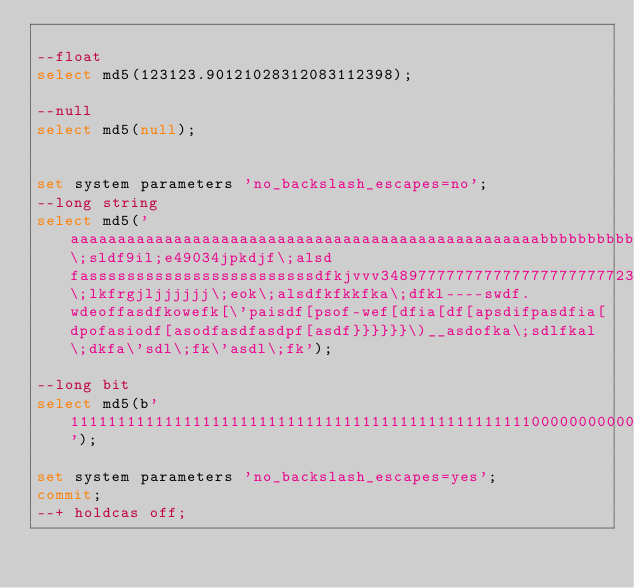<code> <loc_0><loc_0><loc_500><loc_500><_SQL_>
--float
select md5(123123.90121028312083112398);

--null
select md5(null);


set system parameters 'no_backslash_escapes=no';
--long string
select md5('aaaaaaaaaaaaaaaaaaaaaaaaaaaaaaaaaaaaaaaaaaaaaaaaaabbbbbbbbbbbbbbbbbbbbbbbbbbbbblj\;sldf9il;e49034jpkdjf\;alsd fassssssssssssssssssssssssdfkjvvv3489777777777777777777777239488302938402934888888888888880980928340928340289340823498209gks\;lkfrgjljjjjjj\;eok\;alsdfkfkkfka\;dfkl----swdf.wdeoffasdfkowefk[\'paisdf[psof-wef[dfia[df[apsdifpasdfia[dpofasiodf[asodfasdfasdpf[asdf}}}}}}\)__asdofka\;sdlfkal\;dkfa\'sdl\;fk\'asdl\;fk');

--long bit
select md5(b'11111111111111111111111111111111111111111111111110000000000000000000000000000011111111111111111111111111111111111111111111111111111111111111100000000000000000000000000000000000000011111111111111111111111111111111111111111111000000000000000000000000000000000000000000000000000001');

set system parameters 'no_backslash_escapes=yes';
commit;
--+ holdcas off;
</code> 